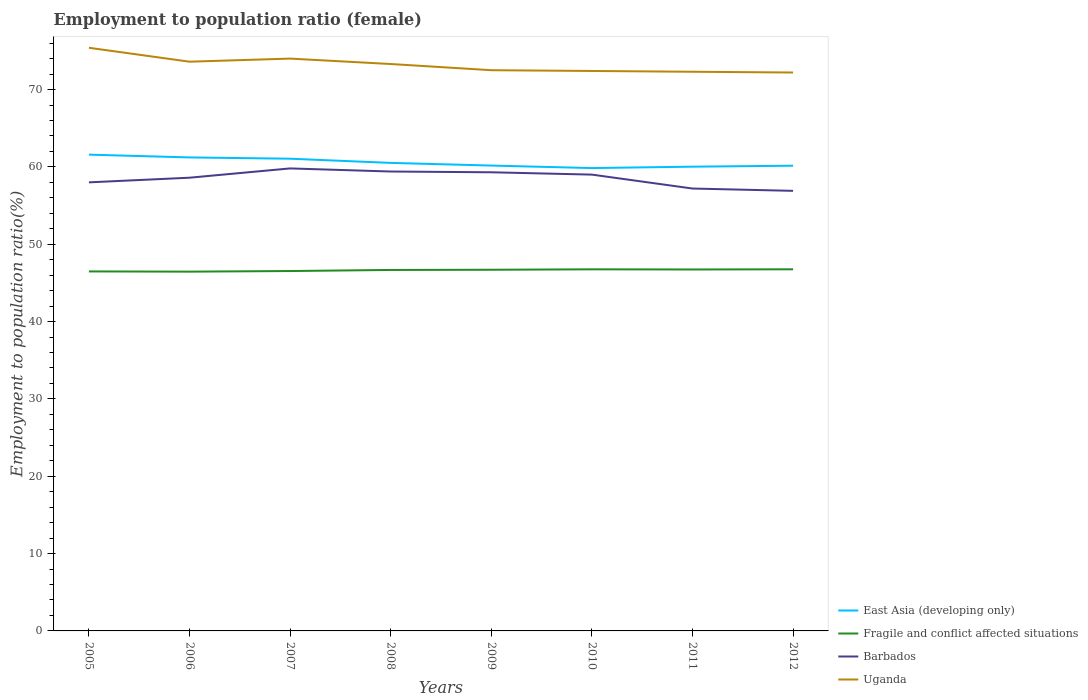Does the line corresponding to Fragile and conflict affected situations intersect with the line corresponding to Barbados?
Give a very brief answer. No. Is the number of lines equal to the number of legend labels?
Your response must be concise. Yes. Across all years, what is the maximum employment to population ratio in Fragile and conflict affected situations?
Offer a very short reply. 46.45. In which year was the employment to population ratio in Barbados maximum?
Your answer should be compact. 2012. What is the total employment to population ratio in Fragile and conflict affected situations in the graph?
Offer a terse response. -0.22. What is the difference between the highest and the second highest employment to population ratio in Barbados?
Make the answer very short. 2.9. What is the difference between the highest and the lowest employment to population ratio in East Asia (developing only)?
Provide a succinct answer. 3. What is the difference between two consecutive major ticks on the Y-axis?
Make the answer very short. 10. Are the values on the major ticks of Y-axis written in scientific E-notation?
Ensure brevity in your answer.  No. Does the graph contain any zero values?
Provide a succinct answer. No. How many legend labels are there?
Your answer should be very brief. 4. What is the title of the graph?
Offer a terse response. Employment to population ratio (female). Does "South Asia" appear as one of the legend labels in the graph?
Ensure brevity in your answer.  No. What is the label or title of the X-axis?
Your answer should be compact. Years. What is the Employment to population ratio(%) in East Asia (developing only) in 2005?
Your answer should be very brief. 61.58. What is the Employment to population ratio(%) of Fragile and conflict affected situations in 2005?
Your answer should be compact. 46.48. What is the Employment to population ratio(%) of Uganda in 2005?
Keep it short and to the point. 75.4. What is the Employment to population ratio(%) in East Asia (developing only) in 2006?
Provide a succinct answer. 61.22. What is the Employment to population ratio(%) of Fragile and conflict affected situations in 2006?
Make the answer very short. 46.45. What is the Employment to population ratio(%) of Barbados in 2006?
Offer a very short reply. 58.6. What is the Employment to population ratio(%) of Uganda in 2006?
Offer a very short reply. 73.6. What is the Employment to population ratio(%) in East Asia (developing only) in 2007?
Your answer should be very brief. 61.06. What is the Employment to population ratio(%) in Fragile and conflict affected situations in 2007?
Your response must be concise. 46.53. What is the Employment to population ratio(%) of Barbados in 2007?
Offer a very short reply. 59.8. What is the Employment to population ratio(%) of East Asia (developing only) in 2008?
Ensure brevity in your answer.  60.52. What is the Employment to population ratio(%) of Fragile and conflict affected situations in 2008?
Provide a succinct answer. 46.67. What is the Employment to population ratio(%) in Barbados in 2008?
Offer a very short reply. 59.4. What is the Employment to population ratio(%) in Uganda in 2008?
Offer a terse response. 73.3. What is the Employment to population ratio(%) in East Asia (developing only) in 2009?
Give a very brief answer. 60.17. What is the Employment to population ratio(%) of Fragile and conflict affected situations in 2009?
Your answer should be compact. 46.7. What is the Employment to population ratio(%) of Barbados in 2009?
Your answer should be compact. 59.3. What is the Employment to population ratio(%) in Uganda in 2009?
Give a very brief answer. 72.5. What is the Employment to population ratio(%) in East Asia (developing only) in 2010?
Provide a succinct answer. 59.85. What is the Employment to population ratio(%) of Fragile and conflict affected situations in 2010?
Offer a very short reply. 46.75. What is the Employment to population ratio(%) of Uganda in 2010?
Give a very brief answer. 72.4. What is the Employment to population ratio(%) of East Asia (developing only) in 2011?
Your answer should be very brief. 60.03. What is the Employment to population ratio(%) of Fragile and conflict affected situations in 2011?
Your answer should be compact. 46.73. What is the Employment to population ratio(%) in Barbados in 2011?
Offer a very short reply. 57.2. What is the Employment to population ratio(%) of Uganda in 2011?
Keep it short and to the point. 72.3. What is the Employment to population ratio(%) of East Asia (developing only) in 2012?
Offer a terse response. 60.15. What is the Employment to population ratio(%) in Fragile and conflict affected situations in 2012?
Your response must be concise. 46.76. What is the Employment to population ratio(%) of Barbados in 2012?
Offer a terse response. 56.9. What is the Employment to population ratio(%) in Uganda in 2012?
Your answer should be compact. 72.2. Across all years, what is the maximum Employment to population ratio(%) in East Asia (developing only)?
Keep it short and to the point. 61.58. Across all years, what is the maximum Employment to population ratio(%) in Fragile and conflict affected situations?
Give a very brief answer. 46.76. Across all years, what is the maximum Employment to population ratio(%) of Barbados?
Provide a short and direct response. 59.8. Across all years, what is the maximum Employment to population ratio(%) of Uganda?
Offer a very short reply. 75.4. Across all years, what is the minimum Employment to population ratio(%) of East Asia (developing only)?
Offer a terse response. 59.85. Across all years, what is the minimum Employment to population ratio(%) of Fragile and conflict affected situations?
Offer a very short reply. 46.45. Across all years, what is the minimum Employment to population ratio(%) in Barbados?
Ensure brevity in your answer.  56.9. Across all years, what is the minimum Employment to population ratio(%) of Uganda?
Give a very brief answer. 72.2. What is the total Employment to population ratio(%) in East Asia (developing only) in the graph?
Ensure brevity in your answer.  484.57. What is the total Employment to population ratio(%) of Fragile and conflict affected situations in the graph?
Give a very brief answer. 373.08. What is the total Employment to population ratio(%) of Barbados in the graph?
Ensure brevity in your answer.  468.2. What is the total Employment to population ratio(%) in Uganda in the graph?
Give a very brief answer. 585.7. What is the difference between the Employment to population ratio(%) of East Asia (developing only) in 2005 and that in 2006?
Offer a terse response. 0.36. What is the difference between the Employment to population ratio(%) in Fragile and conflict affected situations in 2005 and that in 2006?
Make the answer very short. 0.03. What is the difference between the Employment to population ratio(%) in Barbados in 2005 and that in 2006?
Provide a succinct answer. -0.6. What is the difference between the Employment to population ratio(%) in Uganda in 2005 and that in 2006?
Offer a very short reply. 1.8. What is the difference between the Employment to population ratio(%) of East Asia (developing only) in 2005 and that in 2007?
Make the answer very short. 0.53. What is the difference between the Employment to population ratio(%) of Fragile and conflict affected situations in 2005 and that in 2007?
Ensure brevity in your answer.  -0.05. What is the difference between the Employment to population ratio(%) of Barbados in 2005 and that in 2007?
Give a very brief answer. -1.8. What is the difference between the Employment to population ratio(%) of East Asia (developing only) in 2005 and that in 2008?
Provide a short and direct response. 1.07. What is the difference between the Employment to population ratio(%) of Fragile and conflict affected situations in 2005 and that in 2008?
Provide a short and direct response. -0.19. What is the difference between the Employment to population ratio(%) in East Asia (developing only) in 2005 and that in 2009?
Offer a terse response. 1.41. What is the difference between the Employment to population ratio(%) of Fragile and conflict affected situations in 2005 and that in 2009?
Ensure brevity in your answer.  -0.22. What is the difference between the Employment to population ratio(%) in Barbados in 2005 and that in 2009?
Provide a short and direct response. -1.3. What is the difference between the Employment to population ratio(%) in East Asia (developing only) in 2005 and that in 2010?
Make the answer very short. 1.74. What is the difference between the Employment to population ratio(%) in Fragile and conflict affected situations in 2005 and that in 2010?
Your response must be concise. -0.27. What is the difference between the Employment to population ratio(%) of East Asia (developing only) in 2005 and that in 2011?
Make the answer very short. 1.56. What is the difference between the Employment to population ratio(%) in East Asia (developing only) in 2005 and that in 2012?
Your answer should be compact. 1.43. What is the difference between the Employment to population ratio(%) of Fragile and conflict affected situations in 2005 and that in 2012?
Your response must be concise. -0.27. What is the difference between the Employment to population ratio(%) in East Asia (developing only) in 2006 and that in 2007?
Provide a succinct answer. 0.17. What is the difference between the Employment to population ratio(%) in Fragile and conflict affected situations in 2006 and that in 2007?
Give a very brief answer. -0.08. What is the difference between the Employment to population ratio(%) in Uganda in 2006 and that in 2007?
Provide a short and direct response. -0.4. What is the difference between the Employment to population ratio(%) of East Asia (developing only) in 2006 and that in 2008?
Provide a short and direct response. 0.71. What is the difference between the Employment to population ratio(%) in Fragile and conflict affected situations in 2006 and that in 2008?
Ensure brevity in your answer.  -0.22. What is the difference between the Employment to population ratio(%) of East Asia (developing only) in 2006 and that in 2009?
Ensure brevity in your answer.  1.05. What is the difference between the Employment to population ratio(%) in Fragile and conflict affected situations in 2006 and that in 2009?
Your answer should be very brief. -0.25. What is the difference between the Employment to population ratio(%) of Uganda in 2006 and that in 2009?
Make the answer very short. 1.1. What is the difference between the Employment to population ratio(%) in East Asia (developing only) in 2006 and that in 2010?
Provide a short and direct response. 1.38. What is the difference between the Employment to population ratio(%) in Fragile and conflict affected situations in 2006 and that in 2010?
Your response must be concise. -0.3. What is the difference between the Employment to population ratio(%) in Barbados in 2006 and that in 2010?
Keep it short and to the point. -0.4. What is the difference between the Employment to population ratio(%) of East Asia (developing only) in 2006 and that in 2011?
Ensure brevity in your answer.  1.2. What is the difference between the Employment to population ratio(%) in Fragile and conflict affected situations in 2006 and that in 2011?
Make the answer very short. -0.28. What is the difference between the Employment to population ratio(%) of Barbados in 2006 and that in 2011?
Provide a short and direct response. 1.4. What is the difference between the Employment to population ratio(%) of Uganda in 2006 and that in 2011?
Offer a very short reply. 1.3. What is the difference between the Employment to population ratio(%) in East Asia (developing only) in 2006 and that in 2012?
Provide a short and direct response. 1.07. What is the difference between the Employment to population ratio(%) of Fragile and conflict affected situations in 2006 and that in 2012?
Provide a succinct answer. -0.3. What is the difference between the Employment to population ratio(%) in Barbados in 2006 and that in 2012?
Make the answer very short. 1.7. What is the difference between the Employment to population ratio(%) of East Asia (developing only) in 2007 and that in 2008?
Give a very brief answer. 0.54. What is the difference between the Employment to population ratio(%) of Fragile and conflict affected situations in 2007 and that in 2008?
Offer a very short reply. -0.14. What is the difference between the Employment to population ratio(%) of Uganda in 2007 and that in 2008?
Keep it short and to the point. 0.7. What is the difference between the Employment to population ratio(%) in East Asia (developing only) in 2007 and that in 2009?
Ensure brevity in your answer.  0.89. What is the difference between the Employment to population ratio(%) in Fragile and conflict affected situations in 2007 and that in 2009?
Keep it short and to the point. -0.17. What is the difference between the Employment to population ratio(%) in Barbados in 2007 and that in 2009?
Keep it short and to the point. 0.5. What is the difference between the Employment to population ratio(%) in East Asia (developing only) in 2007 and that in 2010?
Give a very brief answer. 1.21. What is the difference between the Employment to population ratio(%) in Fragile and conflict affected situations in 2007 and that in 2010?
Give a very brief answer. -0.22. What is the difference between the Employment to population ratio(%) of Barbados in 2007 and that in 2010?
Provide a succinct answer. 0.8. What is the difference between the Employment to population ratio(%) of Uganda in 2007 and that in 2010?
Provide a short and direct response. 1.6. What is the difference between the Employment to population ratio(%) of East Asia (developing only) in 2007 and that in 2011?
Keep it short and to the point. 1.03. What is the difference between the Employment to population ratio(%) of Fragile and conflict affected situations in 2007 and that in 2011?
Offer a very short reply. -0.2. What is the difference between the Employment to population ratio(%) of Barbados in 2007 and that in 2011?
Keep it short and to the point. 2.6. What is the difference between the Employment to population ratio(%) in East Asia (developing only) in 2007 and that in 2012?
Ensure brevity in your answer.  0.9. What is the difference between the Employment to population ratio(%) in Fragile and conflict affected situations in 2007 and that in 2012?
Ensure brevity in your answer.  -0.22. What is the difference between the Employment to population ratio(%) in Barbados in 2007 and that in 2012?
Make the answer very short. 2.9. What is the difference between the Employment to population ratio(%) of Uganda in 2007 and that in 2012?
Offer a very short reply. 1.8. What is the difference between the Employment to population ratio(%) of East Asia (developing only) in 2008 and that in 2009?
Your response must be concise. 0.34. What is the difference between the Employment to population ratio(%) in Fragile and conflict affected situations in 2008 and that in 2009?
Offer a very short reply. -0.03. What is the difference between the Employment to population ratio(%) in Barbados in 2008 and that in 2009?
Keep it short and to the point. 0.1. What is the difference between the Employment to population ratio(%) of Uganda in 2008 and that in 2009?
Your answer should be very brief. 0.8. What is the difference between the Employment to population ratio(%) in East Asia (developing only) in 2008 and that in 2010?
Keep it short and to the point. 0.67. What is the difference between the Employment to population ratio(%) in Fragile and conflict affected situations in 2008 and that in 2010?
Offer a very short reply. -0.08. What is the difference between the Employment to population ratio(%) in Uganda in 2008 and that in 2010?
Offer a very short reply. 0.9. What is the difference between the Employment to population ratio(%) in East Asia (developing only) in 2008 and that in 2011?
Make the answer very short. 0.49. What is the difference between the Employment to population ratio(%) of Fragile and conflict affected situations in 2008 and that in 2011?
Offer a terse response. -0.06. What is the difference between the Employment to population ratio(%) in Barbados in 2008 and that in 2011?
Keep it short and to the point. 2.2. What is the difference between the Employment to population ratio(%) in Uganda in 2008 and that in 2011?
Keep it short and to the point. 1. What is the difference between the Employment to population ratio(%) in East Asia (developing only) in 2008 and that in 2012?
Offer a very short reply. 0.36. What is the difference between the Employment to population ratio(%) of Fragile and conflict affected situations in 2008 and that in 2012?
Keep it short and to the point. -0.08. What is the difference between the Employment to population ratio(%) in Uganda in 2008 and that in 2012?
Provide a short and direct response. 1.1. What is the difference between the Employment to population ratio(%) of East Asia (developing only) in 2009 and that in 2010?
Ensure brevity in your answer.  0.33. What is the difference between the Employment to population ratio(%) of Fragile and conflict affected situations in 2009 and that in 2010?
Ensure brevity in your answer.  -0.05. What is the difference between the Employment to population ratio(%) of Uganda in 2009 and that in 2010?
Offer a terse response. 0.1. What is the difference between the Employment to population ratio(%) in East Asia (developing only) in 2009 and that in 2011?
Your answer should be very brief. 0.14. What is the difference between the Employment to population ratio(%) of Fragile and conflict affected situations in 2009 and that in 2011?
Your answer should be very brief. -0.03. What is the difference between the Employment to population ratio(%) in Barbados in 2009 and that in 2011?
Keep it short and to the point. 2.1. What is the difference between the Employment to population ratio(%) of Uganda in 2009 and that in 2011?
Provide a succinct answer. 0.2. What is the difference between the Employment to population ratio(%) in East Asia (developing only) in 2009 and that in 2012?
Make the answer very short. 0.02. What is the difference between the Employment to population ratio(%) in Fragile and conflict affected situations in 2009 and that in 2012?
Keep it short and to the point. -0.06. What is the difference between the Employment to population ratio(%) of Barbados in 2009 and that in 2012?
Provide a short and direct response. 2.4. What is the difference between the Employment to population ratio(%) in East Asia (developing only) in 2010 and that in 2011?
Provide a succinct answer. -0.18. What is the difference between the Employment to population ratio(%) in Fragile and conflict affected situations in 2010 and that in 2011?
Offer a terse response. 0.02. What is the difference between the Employment to population ratio(%) of East Asia (developing only) in 2010 and that in 2012?
Keep it short and to the point. -0.31. What is the difference between the Employment to population ratio(%) in Fragile and conflict affected situations in 2010 and that in 2012?
Provide a short and direct response. -0. What is the difference between the Employment to population ratio(%) in Barbados in 2010 and that in 2012?
Ensure brevity in your answer.  2.1. What is the difference between the Employment to population ratio(%) in Uganda in 2010 and that in 2012?
Provide a short and direct response. 0.2. What is the difference between the Employment to population ratio(%) of East Asia (developing only) in 2011 and that in 2012?
Provide a short and direct response. -0.13. What is the difference between the Employment to population ratio(%) in Fragile and conflict affected situations in 2011 and that in 2012?
Your answer should be very brief. -0.02. What is the difference between the Employment to population ratio(%) in Barbados in 2011 and that in 2012?
Your answer should be very brief. 0.3. What is the difference between the Employment to population ratio(%) in Uganda in 2011 and that in 2012?
Offer a very short reply. 0.1. What is the difference between the Employment to population ratio(%) of East Asia (developing only) in 2005 and the Employment to population ratio(%) of Fragile and conflict affected situations in 2006?
Offer a very short reply. 15.13. What is the difference between the Employment to population ratio(%) in East Asia (developing only) in 2005 and the Employment to population ratio(%) in Barbados in 2006?
Offer a very short reply. 2.98. What is the difference between the Employment to population ratio(%) of East Asia (developing only) in 2005 and the Employment to population ratio(%) of Uganda in 2006?
Offer a very short reply. -12.02. What is the difference between the Employment to population ratio(%) in Fragile and conflict affected situations in 2005 and the Employment to population ratio(%) in Barbados in 2006?
Give a very brief answer. -12.12. What is the difference between the Employment to population ratio(%) in Fragile and conflict affected situations in 2005 and the Employment to population ratio(%) in Uganda in 2006?
Ensure brevity in your answer.  -27.12. What is the difference between the Employment to population ratio(%) in Barbados in 2005 and the Employment to population ratio(%) in Uganda in 2006?
Ensure brevity in your answer.  -15.6. What is the difference between the Employment to population ratio(%) in East Asia (developing only) in 2005 and the Employment to population ratio(%) in Fragile and conflict affected situations in 2007?
Keep it short and to the point. 15.05. What is the difference between the Employment to population ratio(%) in East Asia (developing only) in 2005 and the Employment to population ratio(%) in Barbados in 2007?
Your answer should be very brief. 1.78. What is the difference between the Employment to population ratio(%) of East Asia (developing only) in 2005 and the Employment to population ratio(%) of Uganda in 2007?
Give a very brief answer. -12.42. What is the difference between the Employment to population ratio(%) of Fragile and conflict affected situations in 2005 and the Employment to population ratio(%) of Barbados in 2007?
Your answer should be compact. -13.32. What is the difference between the Employment to population ratio(%) in Fragile and conflict affected situations in 2005 and the Employment to population ratio(%) in Uganda in 2007?
Ensure brevity in your answer.  -27.52. What is the difference between the Employment to population ratio(%) in Barbados in 2005 and the Employment to population ratio(%) in Uganda in 2007?
Provide a short and direct response. -16. What is the difference between the Employment to population ratio(%) of East Asia (developing only) in 2005 and the Employment to population ratio(%) of Fragile and conflict affected situations in 2008?
Make the answer very short. 14.91. What is the difference between the Employment to population ratio(%) of East Asia (developing only) in 2005 and the Employment to population ratio(%) of Barbados in 2008?
Your response must be concise. 2.18. What is the difference between the Employment to population ratio(%) in East Asia (developing only) in 2005 and the Employment to population ratio(%) in Uganda in 2008?
Your answer should be compact. -11.72. What is the difference between the Employment to population ratio(%) in Fragile and conflict affected situations in 2005 and the Employment to population ratio(%) in Barbados in 2008?
Your response must be concise. -12.92. What is the difference between the Employment to population ratio(%) in Fragile and conflict affected situations in 2005 and the Employment to population ratio(%) in Uganda in 2008?
Ensure brevity in your answer.  -26.82. What is the difference between the Employment to population ratio(%) of Barbados in 2005 and the Employment to population ratio(%) of Uganda in 2008?
Give a very brief answer. -15.3. What is the difference between the Employment to population ratio(%) of East Asia (developing only) in 2005 and the Employment to population ratio(%) of Fragile and conflict affected situations in 2009?
Keep it short and to the point. 14.88. What is the difference between the Employment to population ratio(%) in East Asia (developing only) in 2005 and the Employment to population ratio(%) in Barbados in 2009?
Ensure brevity in your answer.  2.28. What is the difference between the Employment to population ratio(%) in East Asia (developing only) in 2005 and the Employment to population ratio(%) in Uganda in 2009?
Provide a succinct answer. -10.92. What is the difference between the Employment to population ratio(%) in Fragile and conflict affected situations in 2005 and the Employment to population ratio(%) in Barbados in 2009?
Give a very brief answer. -12.82. What is the difference between the Employment to population ratio(%) in Fragile and conflict affected situations in 2005 and the Employment to population ratio(%) in Uganda in 2009?
Your answer should be very brief. -26.02. What is the difference between the Employment to population ratio(%) of Barbados in 2005 and the Employment to population ratio(%) of Uganda in 2009?
Provide a short and direct response. -14.5. What is the difference between the Employment to population ratio(%) in East Asia (developing only) in 2005 and the Employment to population ratio(%) in Fragile and conflict affected situations in 2010?
Provide a short and direct response. 14.83. What is the difference between the Employment to population ratio(%) of East Asia (developing only) in 2005 and the Employment to population ratio(%) of Barbados in 2010?
Give a very brief answer. 2.58. What is the difference between the Employment to population ratio(%) in East Asia (developing only) in 2005 and the Employment to population ratio(%) in Uganda in 2010?
Your answer should be very brief. -10.82. What is the difference between the Employment to population ratio(%) of Fragile and conflict affected situations in 2005 and the Employment to population ratio(%) of Barbados in 2010?
Make the answer very short. -12.52. What is the difference between the Employment to population ratio(%) in Fragile and conflict affected situations in 2005 and the Employment to population ratio(%) in Uganda in 2010?
Make the answer very short. -25.92. What is the difference between the Employment to population ratio(%) of Barbados in 2005 and the Employment to population ratio(%) of Uganda in 2010?
Offer a very short reply. -14.4. What is the difference between the Employment to population ratio(%) of East Asia (developing only) in 2005 and the Employment to population ratio(%) of Fragile and conflict affected situations in 2011?
Your answer should be compact. 14.85. What is the difference between the Employment to population ratio(%) of East Asia (developing only) in 2005 and the Employment to population ratio(%) of Barbados in 2011?
Keep it short and to the point. 4.38. What is the difference between the Employment to population ratio(%) in East Asia (developing only) in 2005 and the Employment to population ratio(%) in Uganda in 2011?
Your answer should be compact. -10.72. What is the difference between the Employment to population ratio(%) of Fragile and conflict affected situations in 2005 and the Employment to population ratio(%) of Barbados in 2011?
Give a very brief answer. -10.72. What is the difference between the Employment to population ratio(%) of Fragile and conflict affected situations in 2005 and the Employment to population ratio(%) of Uganda in 2011?
Your answer should be very brief. -25.82. What is the difference between the Employment to population ratio(%) of Barbados in 2005 and the Employment to population ratio(%) of Uganda in 2011?
Offer a very short reply. -14.3. What is the difference between the Employment to population ratio(%) of East Asia (developing only) in 2005 and the Employment to population ratio(%) of Fragile and conflict affected situations in 2012?
Ensure brevity in your answer.  14.83. What is the difference between the Employment to population ratio(%) of East Asia (developing only) in 2005 and the Employment to population ratio(%) of Barbados in 2012?
Offer a very short reply. 4.68. What is the difference between the Employment to population ratio(%) in East Asia (developing only) in 2005 and the Employment to population ratio(%) in Uganda in 2012?
Ensure brevity in your answer.  -10.62. What is the difference between the Employment to population ratio(%) of Fragile and conflict affected situations in 2005 and the Employment to population ratio(%) of Barbados in 2012?
Keep it short and to the point. -10.42. What is the difference between the Employment to population ratio(%) in Fragile and conflict affected situations in 2005 and the Employment to population ratio(%) in Uganda in 2012?
Your answer should be compact. -25.72. What is the difference between the Employment to population ratio(%) of East Asia (developing only) in 2006 and the Employment to population ratio(%) of Fragile and conflict affected situations in 2007?
Your answer should be compact. 14.69. What is the difference between the Employment to population ratio(%) in East Asia (developing only) in 2006 and the Employment to population ratio(%) in Barbados in 2007?
Provide a succinct answer. 1.42. What is the difference between the Employment to population ratio(%) of East Asia (developing only) in 2006 and the Employment to population ratio(%) of Uganda in 2007?
Your answer should be compact. -12.78. What is the difference between the Employment to population ratio(%) in Fragile and conflict affected situations in 2006 and the Employment to population ratio(%) in Barbados in 2007?
Make the answer very short. -13.35. What is the difference between the Employment to population ratio(%) in Fragile and conflict affected situations in 2006 and the Employment to population ratio(%) in Uganda in 2007?
Give a very brief answer. -27.55. What is the difference between the Employment to population ratio(%) of Barbados in 2006 and the Employment to population ratio(%) of Uganda in 2007?
Ensure brevity in your answer.  -15.4. What is the difference between the Employment to population ratio(%) of East Asia (developing only) in 2006 and the Employment to population ratio(%) of Fragile and conflict affected situations in 2008?
Make the answer very short. 14.55. What is the difference between the Employment to population ratio(%) in East Asia (developing only) in 2006 and the Employment to population ratio(%) in Barbados in 2008?
Ensure brevity in your answer.  1.82. What is the difference between the Employment to population ratio(%) of East Asia (developing only) in 2006 and the Employment to population ratio(%) of Uganda in 2008?
Make the answer very short. -12.08. What is the difference between the Employment to population ratio(%) in Fragile and conflict affected situations in 2006 and the Employment to population ratio(%) in Barbados in 2008?
Keep it short and to the point. -12.95. What is the difference between the Employment to population ratio(%) in Fragile and conflict affected situations in 2006 and the Employment to population ratio(%) in Uganda in 2008?
Offer a very short reply. -26.85. What is the difference between the Employment to population ratio(%) in Barbados in 2006 and the Employment to population ratio(%) in Uganda in 2008?
Offer a terse response. -14.7. What is the difference between the Employment to population ratio(%) of East Asia (developing only) in 2006 and the Employment to population ratio(%) of Fragile and conflict affected situations in 2009?
Provide a short and direct response. 14.52. What is the difference between the Employment to population ratio(%) in East Asia (developing only) in 2006 and the Employment to population ratio(%) in Barbados in 2009?
Offer a terse response. 1.92. What is the difference between the Employment to population ratio(%) in East Asia (developing only) in 2006 and the Employment to population ratio(%) in Uganda in 2009?
Your response must be concise. -11.28. What is the difference between the Employment to population ratio(%) of Fragile and conflict affected situations in 2006 and the Employment to population ratio(%) of Barbados in 2009?
Provide a succinct answer. -12.85. What is the difference between the Employment to population ratio(%) of Fragile and conflict affected situations in 2006 and the Employment to population ratio(%) of Uganda in 2009?
Give a very brief answer. -26.05. What is the difference between the Employment to population ratio(%) in East Asia (developing only) in 2006 and the Employment to population ratio(%) in Fragile and conflict affected situations in 2010?
Offer a very short reply. 14.47. What is the difference between the Employment to population ratio(%) of East Asia (developing only) in 2006 and the Employment to population ratio(%) of Barbados in 2010?
Provide a succinct answer. 2.22. What is the difference between the Employment to population ratio(%) of East Asia (developing only) in 2006 and the Employment to population ratio(%) of Uganda in 2010?
Offer a very short reply. -11.18. What is the difference between the Employment to population ratio(%) of Fragile and conflict affected situations in 2006 and the Employment to population ratio(%) of Barbados in 2010?
Offer a very short reply. -12.55. What is the difference between the Employment to population ratio(%) in Fragile and conflict affected situations in 2006 and the Employment to population ratio(%) in Uganda in 2010?
Your response must be concise. -25.95. What is the difference between the Employment to population ratio(%) of East Asia (developing only) in 2006 and the Employment to population ratio(%) of Fragile and conflict affected situations in 2011?
Ensure brevity in your answer.  14.49. What is the difference between the Employment to population ratio(%) of East Asia (developing only) in 2006 and the Employment to population ratio(%) of Barbados in 2011?
Make the answer very short. 4.02. What is the difference between the Employment to population ratio(%) of East Asia (developing only) in 2006 and the Employment to population ratio(%) of Uganda in 2011?
Provide a short and direct response. -11.08. What is the difference between the Employment to population ratio(%) in Fragile and conflict affected situations in 2006 and the Employment to population ratio(%) in Barbados in 2011?
Provide a succinct answer. -10.75. What is the difference between the Employment to population ratio(%) in Fragile and conflict affected situations in 2006 and the Employment to population ratio(%) in Uganda in 2011?
Ensure brevity in your answer.  -25.85. What is the difference between the Employment to population ratio(%) in Barbados in 2006 and the Employment to population ratio(%) in Uganda in 2011?
Keep it short and to the point. -13.7. What is the difference between the Employment to population ratio(%) in East Asia (developing only) in 2006 and the Employment to population ratio(%) in Fragile and conflict affected situations in 2012?
Give a very brief answer. 14.47. What is the difference between the Employment to population ratio(%) in East Asia (developing only) in 2006 and the Employment to population ratio(%) in Barbados in 2012?
Offer a very short reply. 4.32. What is the difference between the Employment to population ratio(%) in East Asia (developing only) in 2006 and the Employment to population ratio(%) in Uganda in 2012?
Provide a short and direct response. -10.98. What is the difference between the Employment to population ratio(%) of Fragile and conflict affected situations in 2006 and the Employment to population ratio(%) of Barbados in 2012?
Offer a very short reply. -10.45. What is the difference between the Employment to population ratio(%) in Fragile and conflict affected situations in 2006 and the Employment to population ratio(%) in Uganda in 2012?
Keep it short and to the point. -25.75. What is the difference between the Employment to population ratio(%) of East Asia (developing only) in 2007 and the Employment to population ratio(%) of Fragile and conflict affected situations in 2008?
Give a very brief answer. 14.38. What is the difference between the Employment to population ratio(%) of East Asia (developing only) in 2007 and the Employment to population ratio(%) of Barbados in 2008?
Your answer should be compact. 1.66. What is the difference between the Employment to population ratio(%) in East Asia (developing only) in 2007 and the Employment to population ratio(%) in Uganda in 2008?
Make the answer very short. -12.24. What is the difference between the Employment to population ratio(%) in Fragile and conflict affected situations in 2007 and the Employment to population ratio(%) in Barbados in 2008?
Ensure brevity in your answer.  -12.87. What is the difference between the Employment to population ratio(%) in Fragile and conflict affected situations in 2007 and the Employment to population ratio(%) in Uganda in 2008?
Your answer should be very brief. -26.77. What is the difference between the Employment to population ratio(%) in Barbados in 2007 and the Employment to population ratio(%) in Uganda in 2008?
Provide a short and direct response. -13.5. What is the difference between the Employment to population ratio(%) of East Asia (developing only) in 2007 and the Employment to population ratio(%) of Fragile and conflict affected situations in 2009?
Provide a succinct answer. 14.36. What is the difference between the Employment to population ratio(%) in East Asia (developing only) in 2007 and the Employment to population ratio(%) in Barbados in 2009?
Provide a short and direct response. 1.76. What is the difference between the Employment to population ratio(%) in East Asia (developing only) in 2007 and the Employment to population ratio(%) in Uganda in 2009?
Give a very brief answer. -11.44. What is the difference between the Employment to population ratio(%) of Fragile and conflict affected situations in 2007 and the Employment to population ratio(%) of Barbados in 2009?
Provide a succinct answer. -12.77. What is the difference between the Employment to population ratio(%) in Fragile and conflict affected situations in 2007 and the Employment to population ratio(%) in Uganda in 2009?
Offer a terse response. -25.97. What is the difference between the Employment to population ratio(%) of East Asia (developing only) in 2007 and the Employment to population ratio(%) of Fragile and conflict affected situations in 2010?
Offer a terse response. 14.3. What is the difference between the Employment to population ratio(%) of East Asia (developing only) in 2007 and the Employment to population ratio(%) of Barbados in 2010?
Offer a very short reply. 2.06. What is the difference between the Employment to population ratio(%) in East Asia (developing only) in 2007 and the Employment to population ratio(%) in Uganda in 2010?
Provide a short and direct response. -11.34. What is the difference between the Employment to population ratio(%) of Fragile and conflict affected situations in 2007 and the Employment to population ratio(%) of Barbados in 2010?
Your response must be concise. -12.47. What is the difference between the Employment to population ratio(%) of Fragile and conflict affected situations in 2007 and the Employment to population ratio(%) of Uganda in 2010?
Give a very brief answer. -25.87. What is the difference between the Employment to population ratio(%) in East Asia (developing only) in 2007 and the Employment to population ratio(%) in Fragile and conflict affected situations in 2011?
Give a very brief answer. 14.32. What is the difference between the Employment to population ratio(%) of East Asia (developing only) in 2007 and the Employment to population ratio(%) of Barbados in 2011?
Provide a succinct answer. 3.86. What is the difference between the Employment to population ratio(%) of East Asia (developing only) in 2007 and the Employment to population ratio(%) of Uganda in 2011?
Offer a terse response. -11.24. What is the difference between the Employment to population ratio(%) in Fragile and conflict affected situations in 2007 and the Employment to population ratio(%) in Barbados in 2011?
Keep it short and to the point. -10.67. What is the difference between the Employment to population ratio(%) in Fragile and conflict affected situations in 2007 and the Employment to population ratio(%) in Uganda in 2011?
Offer a terse response. -25.77. What is the difference between the Employment to population ratio(%) of East Asia (developing only) in 2007 and the Employment to population ratio(%) of Fragile and conflict affected situations in 2012?
Your answer should be very brief. 14.3. What is the difference between the Employment to population ratio(%) in East Asia (developing only) in 2007 and the Employment to population ratio(%) in Barbados in 2012?
Offer a terse response. 4.16. What is the difference between the Employment to population ratio(%) of East Asia (developing only) in 2007 and the Employment to population ratio(%) of Uganda in 2012?
Ensure brevity in your answer.  -11.14. What is the difference between the Employment to population ratio(%) in Fragile and conflict affected situations in 2007 and the Employment to population ratio(%) in Barbados in 2012?
Give a very brief answer. -10.37. What is the difference between the Employment to population ratio(%) of Fragile and conflict affected situations in 2007 and the Employment to population ratio(%) of Uganda in 2012?
Give a very brief answer. -25.67. What is the difference between the Employment to population ratio(%) of Barbados in 2007 and the Employment to population ratio(%) of Uganda in 2012?
Ensure brevity in your answer.  -12.4. What is the difference between the Employment to population ratio(%) in East Asia (developing only) in 2008 and the Employment to population ratio(%) in Fragile and conflict affected situations in 2009?
Keep it short and to the point. 13.82. What is the difference between the Employment to population ratio(%) of East Asia (developing only) in 2008 and the Employment to population ratio(%) of Barbados in 2009?
Make the answer very short. 1.22. What is the difference between the Employment to population ratio(%) of East Asia (developing only) in 2008 and the Employment to population ratio(%) of Uganda in 2009?
Make the answer very short. -11.98. What is the difference between the Employment to population ratio(%) of Fragile and conflict affected situations in 2008 and the Employment to population ratio(%) of Barbados in 2009?
Provide a short and direct response. -12.63. What is the difference between the Employment to population ratio(%) in Fragile and conflict affected situations in 2008 and the Employment to population ratio(%) in Uganda in 2009?
Your answer should be compact. -25.83. What is the difference between the Employment to population ratio(%) in East Asia (developing only) in 2008 and the Employment to population ratio(%) in Fragile and conflict affected situations in 2010?
Keep it short and to the point. 13.76. What is the difference between the Employment to population ratio(%) in East Asia (developing only) in 2008 and the Employment to population ratio(%) in Barbados in 2010?
Offer a terse response. 1.51. What is the difference between the Employment to population ratio(%) in East Asia (developing only) in 2008 and the Employment to population ratio(%) in Uganda in 2010?
Your answer should be compact. -11.88. What is the difference between the Employment to population ratio(%) in Fragile and conflict affected situations in 2008 and the Employment to population ratio(%) in Barbados in 2010?
Give a very brief answer. -12.33. What is the difference between the Employment to population ratio(%) of Fragile and conflict affected situations in 2008 and the Employment to population ratio(%) of Uganda in 2010?
Your answer should be very brief. -25.73. What is the difference between the Employment to population ratio(%) of Barbados in 2008 and the Employment to population ratio(%) of Uganda in 2010?
Provide a short and direct response. -13. What is the difference between the Employment to population ratio(%) in East Asia (developing only) in 2008 and the Employment to population ratio(%) in Fragile and conflict affected situations in 2011?
Your answer should be compact. 13.78. What is the difference between the Employment to population ratio(%) in East Asia (developing only) in 2008 and the Employment to population ratio(%) in Barbados in 2011?
Ensure brevity in your answer.  3.31. What is the difference between the Employment to population ratio(%) in East Asia (developing only) in 2008 and the Employment to population ratio(%) in Uganda in 2011?
Offer a very short reply. -11.79. What is the difference between the Employment to population ratio(%) in Fragile and conflict affected situations in 2008 and the Employment to population ratio(%) in Barbados in 2011?
Ensure brevity in your answer.  -10.53. What is the difference between the Employment to population ratio(%) of Fragile and conflict affected situations in 2008 and the Employment to population ratio(%) of Uganda in 2011?
Offer a very short reply. -25.63. What is the difference between the Employment to population ratio(%) of East Asia (developing only) in 2008 and the Employment to population ratio(%) of Fragile and conflict affected situations in 2012?
Ensure brevity in your answer.  13.76. What is the difference between the Employment to population ratio(%) of East Asia (developing only) in 2008 and the Employment to population ratio(%) of Barbados in 2012?
Provide a succinct answer. 3.62. What is the difference between the Employment to population ratio(%) in East Asia (developing only) in 2008 and the Employment to population ratio(%) in Uganda in 2012?
Provide a short and direct response. -11.69. What is the difference between the Employment to population ratio(%) in Fragile and conflict affected situations in 2008 and the Employment to population ratio(%) in Barbados in 2012?
Provide a succinct answer. -10.23. What is the difference between the Employment to population ratio(%) in Fragile and conflict affected situations in 2008 and the Employment to population ratio(%) in Uganda in 2012?
Provide a short and direct response. -25.53. What is the difference between the Employment to population ratio(%) in Barbados in 2008 and the Employment to population ratio(%) in Uganda in 2012?
Offer a terse response. -12.8. What is the difference between the Employment to population ratio(%) in East Asia (developing only) in 2009 and the Employment to population ratio(%) in Fragile and conflict affected situations in 2010?
Your answer should be compact. 13.42. What is the difference between the Employment to population ratio(%) in East Asia (developing only) in 2009 and the Employment to population ratio(%) in Barbados in 2010?
Ensure brevity in your answer.  1.17. What is the difference between the Employment to population ratio(%) of East Asia (developing only) in 2009 and the Employment to population ratio(%) of Uganda in 2010?
Offer a very short reply. -12.23. What is the difference between the Employment to population ratio(%) of Fragile and conflict affected situations in 2009 and the Employment to population ratio(%) of Barbados in 2010?
Provide a short and direct response. -12.3. What is the difference between the Employment to population ratio(%) in Fragile and conflict affected situations in 2009 and the Employment to population ratio(%) in Uganda in 2010?
Provide a short and direct response. -25.7. What is the difference between the Employment to population ratio(%) in Barbados in 2009 and the Employment to population ratio(%) in Uganda in 2010?
Ensure brevity in your answer.  -13.1. What is the difference between the Employment to population ratio(%) in East Asia (developing only) in 2009 and the Employment to population ratio(%) in Fragile and conflict affected situations in 2011?
Give a very brief answer. 13.44. What is the difference between the Employment to population ratio(%) in East Asia (developing only) in 2009 and the Employment to population ratio(%) in Barbados in 2011?
Provide a short and direct response. 2.97. What is the difference between the Employment to population ratio(%) of East Asia (developing only) in 2009 and the Employment to population ratio(%) of Uganda in 2011?
Keep it short and to the point. -12.13. What is the difference between the Employment to population ratio(%) in Fragile and conflict affected situations in 2009 and the Employment to population ratio(%) in Barbados in 2011?
Your answer should be very brief. -10.5. What is the difference between the Employment to population ratio(%) of Fragile and conflict affected situations in 2009 and the Employment to population ratio(%) of Uganda in 2011?
Your response must be concise. -25.6. What is the difference between the Employment to population ratio(%) of Barbados in 2009 and the Employment to population ratio(%) of Uganda in 2011?
Provide a succinct answer. -13. What is the difference between the Employment to population ratio(%) in East Asia (developing only) in 2009 and the Employment to population ratio(%) in Fragile and conflict affected situations in 2012?
Keep it short and to the point. 13.41. What is the difference between the Employment to population ratio(%) in East Asia (developing only) in 2009 and the Employment to population ratio(%) in Barbados in 2012?
Provide a succinct answer. 3.27. What is the difference between the Employment to population ratio(%) of East Asia (developing only) in 2009 and the Employment to population ratio(%) of Uganda in 2012?
Your response must be concise. -12.03. What is the difference between the Employment to population ratio(%) in Fragile and conflict affected situations in 2009 and the Employment to population ratio(%) in Barbados in 2012?
Make the answer very short. -10.2. What is the difference between the Employment to population ratio(%) in Fragile and conflict affected situations in 2009 and the Employment to population ratio(%) in Uganda in 2012?
Provide a succinct answer. -25.5. What is the difference between the Employment to population ratio(%) in East Asia (developing only) in 2010 and the Employment to population ratio(%) in Fragile and conflict affected situations in 2011?
Provide a short and direct response. 13.11. What is the difference between the Employment to population ratio(%) of East Asia (developing only) in 2010 and the Employment to population ratio(%) of Barbados in 2011?
Your answer should be very brief. 2.65. What is the difference between the Employment to population ratio(%) in East Asia (developing only) in 2010 and the Employment to population ratio(%) in Uganda in 2011?
Your answer should be compact. -12.45. What is the difference between the Employment to population ratio(%) of Fragile and conflict affected situations in 2010 and the Employment to population ratio(%) of Barbados in 2011?
Keep it short and to the point. -10.45. What is the difference between the Employment to population ratio(%) of Fragile and conflict affected situations in 2010 and the Employment to population ratio(%) of Uganda in 2011?
Your response must be concise. -25.55. What is the difference between the Employment to population ratio(%) of East Asia (developing only) in 2010 and the Employment to population ratio(%) of Fragile and conflict affected situations in 2012?
Provide a succinct answer. 13.09. What is the difference between the Employment to population ratio(%) in East Asia (developing only) in 2010 and the Employment to population ratio(%) in Barbados in 2012?
Provide a succinct answer. 2.95. What is the difference between the Employment to population ratio(%) of East Asia (developing only) in 2010 and the Employment to population ratio(%) of Uganda in 2012?
Your answer should be very brief. -12.35. What is the difference between the Employment to population ratio(%) in Fragile and conflict affected situations in 2010 and the Employment to population ratio(%) in Barbados in 2012?
Ensure brevity in your answer.  -10.15. What is the difference between the Employment to population ratio(%) in Fragile and conflict affected situations in 2010 and the Employment to population ratio(%) in Uganda in 2012?
Offer a terse response. -25.45. What is the difference between the Employment to population ratio(%) of Barbados in 2010 and the Employment to population ratio(%) of Uganda in 2012?
Your response must be concise. -13.2. What is the difference between the Employment to population ratio(%) in East Asia (developing only) in 2011 and the Employment to population ratio(%) in Fragile and conflict affected situations in 2012?
Your answer should be compact. 13.27. What is the difference between the Employment to population ratio(%) in East Asia (developing only) in 2011 and the Employment to population ratio(%) in Barbados in 2012?
Your answer should be compact. 3.13. What is the difference between the Employment to population ratio(%) of East Asia (developing only) in 2011 and the Employment to population ratio(%) of Uganda in 2012?
Give a very brief answer. -12.17. What is the difference between the Employment to population ratio(%) in Fragile and conflict affected situations in 2011 and the Employment to population ratio(%) in Barbados in 2012?
Make the answer very short. -10.17. What is the difference between the Employment to population ratio(%) of Fragile and conflict affected situations in 2011 and the Employment to population ratio(%) of Uganda in 2012?
Your answer should be compact. -25.47. What is the difference between the Employment to population ratio(%) of Barbados in 2011 and the Employment to population ratio(%) of Uganda in 2012?
Give a very brief answer. -15. What is the average Employment to population ratio(%) of East Asia (developing only) per year?
Your answer should be very brief. 60.57. What is the average Employment to population ratio(%) in Fragile and conflict affected situations per year?
Keep it short and to the point. 46.64. What is the average Employment to population ratio(%) in Barbados per year?
Keep it short and to the point. 58.52. What is the average Employment to population ratio(%) in Uganda per year?
Make the answer very short. 73.21. In the year 2005, what is the difference between the Employment to population ratio(%) in East Asia (developing only) and Employment to population ratio(%) in Fragile and conflict affected situations?
Keep it short and to the point. 15.1. In the year 2005, what is the difference between the Employment to population ratio(%) of East Asia (developing only) and Employment to population ratio(%) of Barbados?
Provide a succinct answer. 3.58. In the year 2005, what is the difference between the Employment to population ratio(%) in East Asia (developing only) and Employment to population ratio(%) in Uganda?
Offer a terse response. -13.82. In the year 2005, what is the difference between the Employment to population ratio(%) of Fragile and conflict affected situations and Employment to population ratio(%) of Barbados?
Your answer should be compact. -11.52. In the year 2005, what is the difference between the Employment to population ratio(%) in Fragile and conflict affected situations and Employment to population ratio(%) in Uganda?
Your response must be concise. -28.92. In the year 2005, what is the difference between the Employment to population ratio(%) of Barbados and Employment to population ratio(%) of Uganda?
Provide a succinct answer. -17.4. In the year 2006, what is the difference between the Employment to population ratio(%) of East Asia (developing only) and Employment to population ratio(%) of Fragile and conflict affected situations?
Provide a short and direct response. 14.77. In the year 2006, what is the difference between the Employment to population ratio(%) in East Asia (developing only) and Employment to population ratio(%) in Barbados?
Offer a terse response. 2.62. In the year 2006, what is the difference between the Employment to population ratio(%) of East Asia (developing only) and Employment to population ratio(%) of Uganda?
Your answer should be compact. -12.38. In the year 2006, what is the difference between the Employment to population ratio(%) of Fragile and conflict affected situations and Employment to population ratio(%) of Barbados?
Provide a short and direct response. -12.15. In the year 2006, what is the difference between the Employment to population ratio(%) of Fragile and conflict affected situations and Employment to population ratio(%) of Uganda?
Your answer should be very brief. -27.15. In the year 2006, what is the difference between the Employment to population ratio(%) in Barbados and Employment to population ratio(%) in Uganda?
Provide a short and direct response. -15. In the year 2007, what is the difference between the Employment to population ratio(%) of East Asia (developing only) and Employment to population ratio(%) of Fragile and conflict affected situations?
Ensure brevity in your answer.  14.52. In the year 2007, what is the difference between the Employment to population ratio(%) in East Asia (developing only) and Employment to population ratio(%) in Barbados?
Provide a short and direct response. 1.26. In the year 2007, what is the difference between the Employment to population ratio(%) in East Asia (developing only) and Employment to population ratio(%) in Uganda?
Provide a succinct answer. -12.94. In the year 2007, what is the difference between the Employment to population ratio(%) of Fragile and conflict affected situations and Employment to population ratio(%) of Barbados?
Offer a very short reply. -13.27. In the year 2007, what is the difference between the Employment to population ratio(%) in Fragile and conflict affected situations and Employment to population ratio(%) in Uganda?
Your response must be concise. -27.47. In the year 2008, what is the difference between the Employment to population ratio(%) of East Asia (developing only) and Employment to population ratio(%) of Fragile and conflict affected situations?
Offer a very short reply. 13.84. In the year 2008, what is the difference between the Employment to population ratio(%) of East Asia (developing only) and Employment to population ratio(%) of Barbados?
Your answer should be very brief. 1.11. In the year 2008, what is the difference between the Employment to population ratio(%) in East Asia (developing only) and Employment to population ratio(%) in Uganda?
Offer a very short reply. -12.79. In the year 2008, what is the difference between the Employment to population ratio(%) in Fragile and conflict affected situations and Employment to population ratio(%) in Barbados?
Keep it short and to the point. -12.73. In the year 2008, what is the difference between the Employment to population ratio(%) in Fragile and conflict affected situations and Employment to population ratio(%) in Uganda?
Ensure brevity in your answer.  -26.63. In the year 2008, what is the difference between the Employment to population ratio(%) in Barbados and Employment to population ratio(%) in Uganda?
Give a very brief answer. -13.9. In the year 2009, what is the difference between the Employment to population ratio(%) of East Asia (developing only) and Employment to population ratio(%) of Fragile and conflict affected situations?
Ensure brevity in your answer.  13.47. In the year 2009, what is the difference between the Employment to population ratio(%) of East Asia (developing only) and Employment to population ratio(%) of Barbados?
Keep it short and to the point. 0.87. In the year 2009, what is the difference between the Employment to population ratio(%) in East Asia (developing only) and Employment to population ratio(%) in Uganda?
Offer a very short reply. -12.33. In the year 2009, what is the difference between the Employment to population ratio(%) of Fragile and conflict affected situations and Employment to population ratio(%) of Barbados?
Provide a succinct answer. -12.6. In the year 2009, what is the difference between the Employment to population ratio(%) of Fragile and conflict affected situations and Employment to population ratio(%) of Uganda?
Your answer should be compact. -25.8. In the year 2010, what is the difference between the Employment to population ratio(%) in East Asia (developing only) and Employment to population ratio(%) in Fragile and conflict affected situations?
Offer a terse response. 13.09. In the year 2010, what is the difference between the Employment to population ratio(%) in East Asia (developing only) and Employment to population ratio(%) in Barbados?
Make the answer very short. 0.85. In the year 2010, what is the difference between the Employment to population ratio(%) of East Asia (developing only) and Employment to population ratio(%) of Uganda?
Provide a succinct answer. -12.55. In the year 2010, what is the difference between the Employment to population ratio(%) in Fragile and conflict affected situations and Employment to population ratio(%) in Barbados?
Keep it short and to the point. -12.25. In the year 2010, what is the difference between the Employment to population ratio(%) in Fragile and conflict affected situations and Employment to population ratio(%) in Uganda?
Your answer should be compact. -25.65. In the year 2011, what is the difference between the Employment to population ratio(%) of East Asia (developing only) and Employment to population ratio(%) of Fragile and conflict affected situations?
Offer a terse response. 13.29. In the year 2011, what is the difference between the Employment to population ratio(%) in East Asia (developing only) and Employment to population ratio(%) in Barbados?
Offer a terse response. 2.83. In the year 2011, what is the difference between the Employment to population ratio(%) in East Asia (developing only) and Employment to population ratio(%) in Uganda?
Provide a short and direct response. -12.27. In the year 2011, what is the difference between the Employment to population ratio(%) in Fragile and conflict affected situations and Employment to population ratio(%) in Barbados?
Keep it short and to the point. -10.47. In the year 2011, what is the difference between the Employment to population ratio(%) of Fragile and conflict affected situations and Employment to population ratio(%) of Uganda?
Your answer should be very brief. -25.57. In the year 2011, what is the difference between the Employment to population ratio(%) of Barbados and Employment to population ratio(%) of Uganda?
Offer a very short reply. -15.1. In the year 2012, what is the difference between the Employment to population ratio(%) in East Asia (developing only) and Employment to population ratio(%) in Fragile and conflict affected situations?
Make the answer very short. 13.39. In the year 2012, what is the difference between the Employment to population ratio(%) of East Asia (developing only) and Employment to population ratio(%) of Barbados?
Your answer should be very brief. 3.25. In the year 2012, what is the difference between the Employment to population ratio(%) of East Asia (developing only) and Employment to population ratio(%) of Uganda?
Provide a succinct answer. -12.05. In the year 2012, what is the difference between the Employment to population ratio(%) in Fragile and conflict affected situations and Employment to population ratio(%) in Barbados?
Your answer should be very brief. -10.14. In the year 2012, what is the difference between the Employment to population ratio(%) of Fragile and conflict affected situations and Employment to population ratio(%) of Uganda?
Keep it short and to the point. -25.44. In the year 2012, what is the difference between the Employment to population ratio(%) in Barbados and Employment to population ratio(%) in Uganda?
Keep it short and to the point. -15.3. What is the ratio of the Employment to population ratio(%) in East Asia (developing only) in 2005 to that in 2006?
Offer a terse response. 1.01. What is the ratio of the Employment to population ratio(%) of Uganda in 2005 to that in 2006?
Offer a terse response. 1.02. What is the ratio of the Employment to population ratio(%) in East Asia (developing only) in 2005 to that in 2007?
Provide a short and direct response. 1.01. What is the ratio of the Employment to population ratio(%) in Barbados in 2005 to that in 2007?
Provide a short and direct response. 0.97. What is the ratio of the Employment to population ratio(%) in Uganda in 2005 to that in 2007?
Ensure brevity in your answer.  1.02. What is the ratio of the Employment to population ratio(%) in East Asia (developing only) in 2005 to that in 2008?
Your response must be concise. 1.02. What is the ratio of the Employment to population ratio(%) of Fragile and conflict affected situations in 2005 to that in 2008?
Make the answer very short. 1. What is the ratio of the Employment to population ratio(%) of Barbados in 2005 to that in 2008?
Your response must be concise. 0.98. What is the ratio of the Employment to population ratio(%) in Uganda in 2005 to that in 2008?
Give a very brief answer. 1.03. What is the ratio of the Employment to population ratio(%) in East Asia (developing only) in 2005 to that in 2009?
Provide a succinct answer. 1.02. What is the ratio of the Employment to population ratio(%) in Fragile and conflict affected situations in 2005 to that in 2009?
Provide a succinct answer. 1. What is the ratio of the Employment to population ratio(%) of Barbados in 2005 to that in 2009?
Give a very brief answer. 0.98. What is the ratio of the Employment to population ratio(%) in East Asia (developing only) in 2005 to that in 2010?
Your response must be concise. 1.03. What is the ratio of the Employment to population ratio(%) in Barbados in 2005 to that in 2010?
Make the answer very short. 0.98. What is the ratio of the Employment to population ratio(%) of Uganda in 2005 to that in 2010?
Your answer should be very brief. 1.04. What is the ratio of the Employment to population ratio(%) of East Asia (developing only) in 2005 to that in 2011?
Provide a succinct answer. 1.03. What is the ratio of the Employment to population ratio(%) of Barbados in 2005 to that in 2011?
Make the answer very short. 1.01. What is the ratio of the Employment to population ratio(%) of Uganda in 2005 to that in 2011?
Offer a very short reply. 1.04. What is the ratio of the Employment to population ratio(%) of East Asia (developing only) in 2005 to that in 2012?
Your response must be concise. 1.02. What is the ratio of the Employment to population ratio(%) in Fragile and conflict affected situations in 2005 to that in 2012?
Provide a short and direct response. 0.99. What is the ratio of the Employment to population ratio(%) of Barbados in 2005 to that in 2012?
Give a very brief answer. 1.02. What is the ratio of the Employment to population ratio(%) in Uganda in 2005 to that in 2012?
Provide a short and direct response. 1.04. What is the ratio of the Employment to population ratio(%) in East Asia (developing only) in 2006 to that in 2007?
Provide a short and direct response. 1. What is the ratio of the Employment to population ratio(%) in Fragile and conflict affected situations in 2006 to that in 2007?
Offer a very short reply. 1. What is the ratio of the Employment to population ratio(%) of Barbados in 2006 to that in 2007?
Your answer should be very brief. 0.98. What is the ratio of the Employment to population ratio(%) of Uganda in 2006 to that in 2007?
Offer a terse response. 0.99. What is the ratio of the Employment to population ratio(%) in East Asia (developing only) in 2006 to that in 2008?
Your answer should be compact. 1.01. What is the ratio of the Employment to population ratio(%) in Barbados in 2006 to that in 2008?
Your answer should be very brief. 0.99. What is the ratio of the Employment to population ratio(%) in Uganda in 2006 to that in 2008?
Your answer should be compact. 1. What is the ratio of the Employment to population ratio(%) in East Asia (developing only) in 2006 to that in 2009?
Keep it short and to the point. 1.02. What is the ratio of the Employment to population ratio(%) in Fragile and conflict affected situations in 2006 to that in 2009?
Make the answer very short. 0.99. What is the ratio of the Employment to population ratio(%) of Uganda in 2006 to that in 2009?
Offer a very short reply. 1.02. What is the ratio of the Employment to population ratio(%) of East Asia (developing only) in 2006 to that in 2010?
Provide a short and direct response. 1.02. What is the ratio of the Employment to population ratio(%) in Fragile and conflict affected situations in 2006 to that in 2010?
Provide a short and direct response. 0.99. What is the ratio of the Employment to population ratio(%) of Uganda in 2006 to that in 2010?
Your response must be concise. 1.02. What is the ratio of the Employment to population ratio(%) in East Asia (developing only) in 2006 to that in 2011?
Offer a terse response. 1.02. What is the ratio of the Employment to population ratio(%) in Barbados in 2006 to that in 2011?
Your answer should be compact. 1.02. What is the ratio of the Employment to population ratio(%) of Uganda in 2006 to that in 2011?
Your response must be concise. 1.02. What is the ratio of the Employment to population ratio(%) in East Asia (developing only) in 2006 to that in 2012?
Your answer should be very brief. 1.02. What is the ratio of the Employment to population ratio(%) of Fragile and conflict affected situations in 2006 to that in 2012?
Make the answer very short. 0.99. What is the ratio of the Employment to population ratio(%) in Barbados in 2006 to that in 2012?
Keep it short and to the point. 1.03. What is the ratio of the Employment to population ratio(%) of Uganda in 2006 to that in 2012?
Your response must be concise. 1.02. What is the ratio of the Employment to population ratio(%) of East Asia (developing only) in 2007 to that in 2008?
Provide a short and direct response. 1.01. What is the ratio of the Employment to population ratio(%) of Fragile and conflict affected situations in 2007 to that in 2008?
Make the answer very short. 1. What is the ratio of the Employment to population ratio(%) in Uganda in 2007 to that in 2008?
Provide a succinct answer. 1.01. What is the ratio of the Employment to population ratio(%) of East Asia (developing only) in 2007 to that in 2009?
Your response must be concise. 1.01. What is the ratio of the Employment to population ratio(%) in Barbados in 2007 to that in 2009?
Your answer should be compact. 1.01. What is the ratio of the Employment to population ratio(%) in Uganda in 2007 to that in 2009?
Offer a very short reply. 1.02. What is the ratio of the Employment to population ratio(%) of East Asia (developing only) in 2007 to that in 2010?
Make the answer very short. 1.02. What is the ratio of the Employment to population ratio(%) in Barbados in 2007 to that in 2010?
Provide a succinct answer. 1.01. What is the ratio of the Employment to population ratio(%) in Uganda in 2007 to that in 2010?
Provide a short and direct response. 1.02. What is the ratio of the Employment to population ratio(%) in East Asia (developing only) in 2007 to that in 2011?
Offer a terse response. 1.02. What is the ratio of the Employment to population ratio(%) in Fragile and conflict affected situations in 2007 to that in 2011?
Provide a short and direct response. 1. What is the ratio of the Employment to population ratio(%) in Barbados in 2007 to that in 2011?
Offer a very short reply. 1.05. What is the ratio of the Employment to population ratio(%) in Uganda in 2007 to that in 2011?
Give a very brief answer. 1.02. What is the ratio of the Employment to population ratio(%) in Fragile and conflict affected situations in 2007 to that in 2012?
Give a very brief answer. 1. What is the ratio of the Employment to population ratio(%) of Barbados in 2007 to that in 2012?
Your answer should be very brief. 1.05. What is the ratio of the Employment to population ratio(%) in Uganda in 2007 to that in 2012?
Provide a succinct answer. 1.02. What is the ratio of the Employment to population ratio(%) of Uganda in 2008 to that in 2009?
Provide a short and direct response. 1.01. What is the ratio of the Employment to population ratio(%) of East Asia (developing only) in 2008 to that in 2010?
Offer a very short reply. 1.01. What is the ratio of the Employment to population ratio(%) in Barbados in 2008 to that in 2010?
Keep it short and to the point. 1.01. What is the ratio of the Employment to population ratio(%) of Uganda in 2008 to that in 2010?
Keep it short and to the point. 1.01. What is the ratio of the Employment to population ratio(%) of Fragile and conflict affected situations in 2008 to that in 2011?
Offer a very short reply. 1. What is the ratio of the Employment to population ratio(%) of Uganda in 2008 to that in 2011?
Offer a terse response. 1.01. What is the ratio of the Employment to population ratio(%) in Barbados in 2008 to that in 2012?
Offer a terse response. 1.04. What is the ratio of the Employment to population ratio(%) in Uganda in 2008 to that in 2012?
Give a very brief answer. 1.02. What is the ratio of the Employment to population ratio(%) in East Asia (developing only) in 2009 to that in 2010?
Your answer should be compact. 1.01. What is the ratio of the Employment to population ratio(%) of Fragile and conflict affected situations in 2009 to that in 2010?
Provide a succinct answer. 1. What is the ratio of the Employment to population ratio(%) in Fragile and conflict affected situations in 2009 to that in 2011?
Keep it short and to the point. 1. What is the ratio of the Employment to population ratio(%) of Barbados in 2009 to that in 2011?
Your answer should be compact. 1.04. What is the ratio of the Employment to population ratio(%) in East Asia (developing only) in 2009 to that in 2012?
Your response must be concise. 1. What is the ratio of the Employment to population ratio(%) of Barbados in 2009 to that in 2012?
Your answer should be compact. 1.04. What is the ratio of the Employment to population ratio(%) in Barbados in 2010 to that in 2011?
Provide a succinct answer. 1.03. What is the ratio of the Employment to population ratio(%) of Barbados in 2010 to that in 2012?
Offer a very short reply. 1.04. What is the ratio of the Employment to population ratio(%) of Fragile and conflict affected situations in 2011 to that in 2012?
Your answer should be compact. 1. What is the difference between the highest and the second highest Employment to population ratio(%) of East Asia (developing only)?
Ensure brevity in your answer.  0.36. What is the difference between the highest and the second highest Employment to population ratio(%) in Fragile and conflict affected situations?
Your answer should be very brief. 0. What is the difference between the highest and the lowest Employment to population ratio(%) in East Asia (developing only)?
Offer a very short reply. 1.74. What is the difference between the highest and the lowest Employment to population ratio(%) of Fragile and conflict affected situations?
Provide a succinct answer. 0.3. What is the difference between the highest and the lowest Employment to population ratio(%) in Barbados?
Make the answer very short. 2.9. 